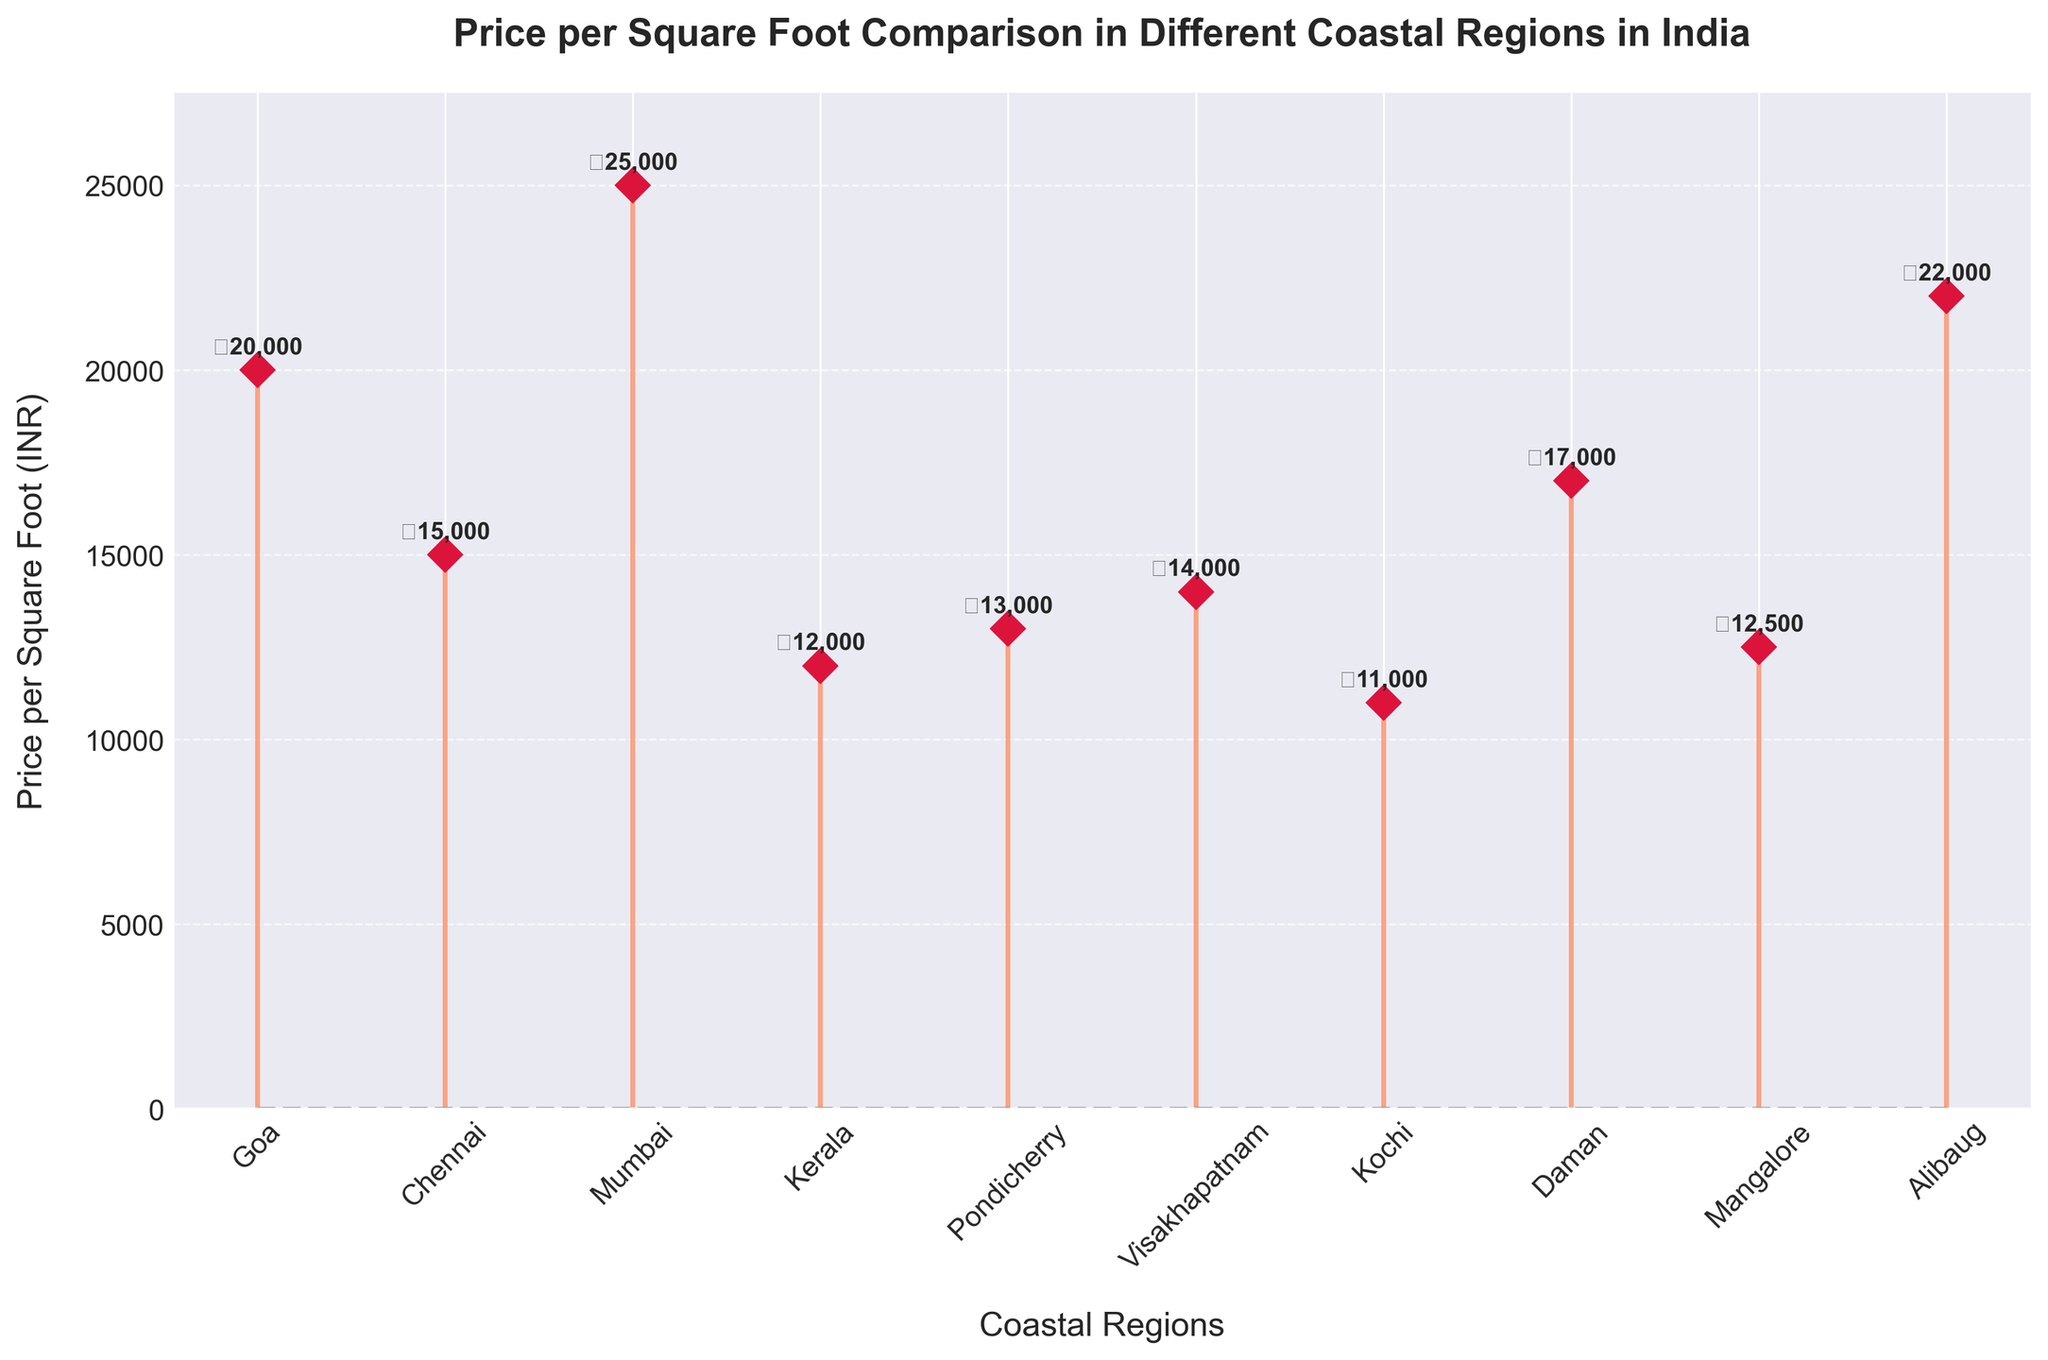What is the title of the figure? The title is located at the top of the plot, usually centered. This information helps identify the main theme or comparison being visualized.
Answer: Price per Square Foot Comparison in Different Coastal Regions in India Which region has the highest price per square foot? By looking at the highest stem line on the figure, it is clear which region has the maximum price per square foot.
Answer: Mumbai What is the price per square foot in Goa? By locating Goa on the x-axis and following the stem line to its top, we find the price per square foot noted there.
Answer: 20,000 INR How much more expensive is the price per square foot in Mumbai compared to Kochi? Identify and subtract the price per square foot in Kochi from that in Mumbai: 25,000 – 11,000 = 14,000 INR.
Answer: 14,000 INR Which regions have a price per square foot less than 15,000 INR? Identify all regions whose stem lines fall below the 15,000 INR mark on the y-axis.
Answer: Kerala, Pondicherry, Visakhapatnam, Kochi, Mangalore What is the average price per square foot across all regions? Sum all the prices and divide by the number of regions: (20,000 + 15,000 + 25,000 + 12,000 + 13,000 + 14,000 + 11,000 + 17,000 + 12,500 + 22,000) / 10 = 161,500 / 10 = 16,150 INR.
Answer: 16,150 INR Is the price per square foot in Daman closer to the highest or the lowest price point in the graph? Compare the price in Daman with the highest price (25,000 INR in Mumbai) and the lowest price (11,000 INR in Kochi). Distance to highest: 25,000 - 17,000 = 8,000. Distance to lowest: 17,000 - 11,000 = 6,000.
Answer: Lowest Which regions have prices within 1,000 INR of each other? Look for regions with prices that differ by no more than 1,000 INR by comparing their respective stem line heights on the plot.
Answer: Kerala and Mangalore; Pondicherry and Visakhapatnam Which region has the lowest price per square foot, and what is its value? Identify the shortest stem line on the plot and read its corresponding value.
Answer: Kochi, 11,000 INR Are there more regions with prices above 15,000 INR or below 15,000 INR? Count and compare the number of regions with stem lines above and below 15,000 INR. Above: 5 regions, Below: 5 regions.
Answer: Equal amount 